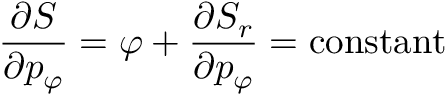<formula> <loc_0><loc_0><loc_500><loc_500>{ \frac { \partial S } { \partial p _ { \varphi } } } = \varphi + { \frac { \partial S _ { r } } { \partial p _ { \varphi } } } = c o n s t a n t</formula> 